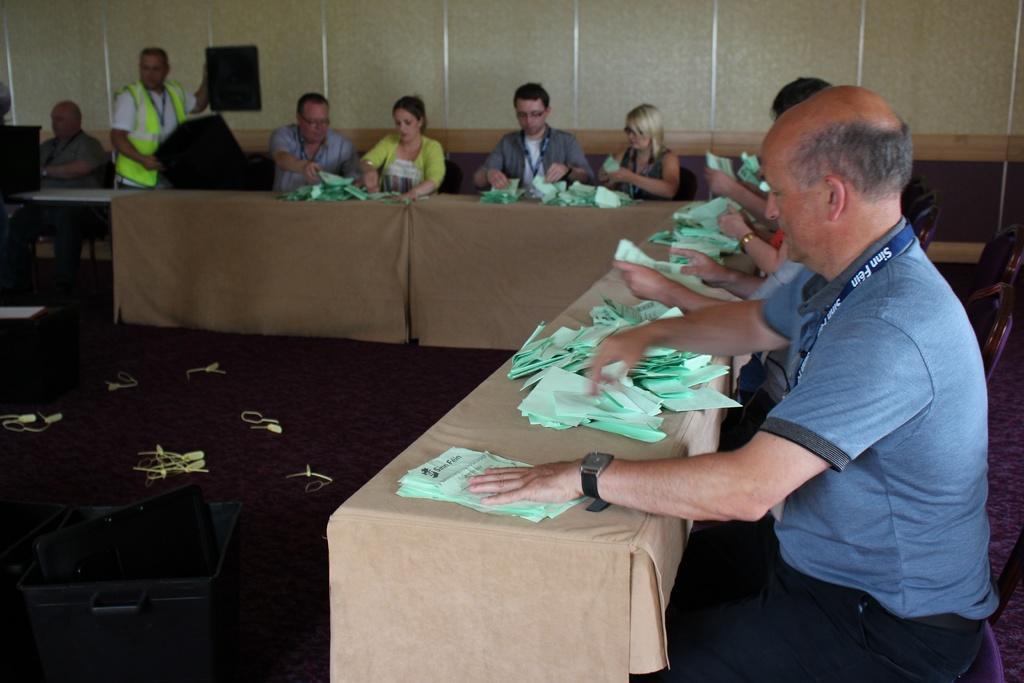Please provide a concise description of this image. In this picture there are group of people sitting on the chairs, there is a long table before them and all are arranging the papers accordingly, there is a black color box at the left side of the image. 